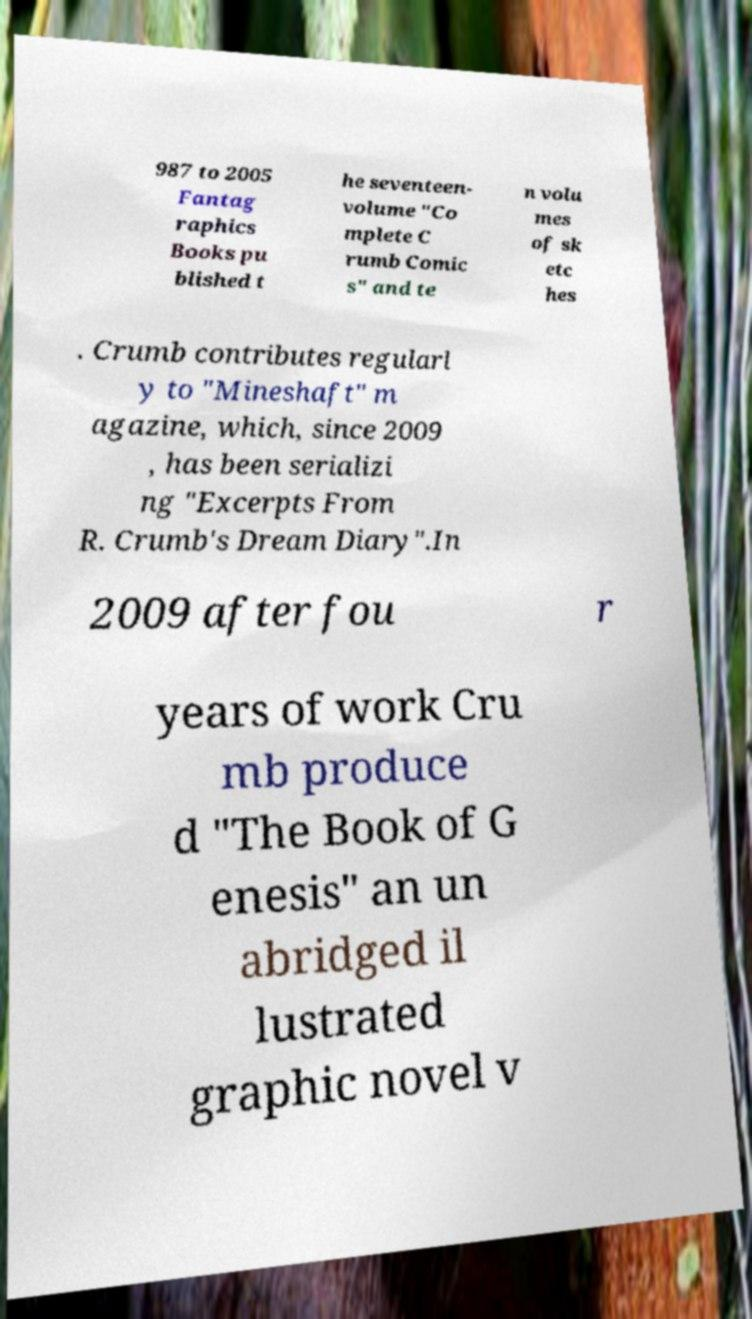For documentation purposes, I need the text within this image transcribed. Could you provide that? 987 to 2005 Fantag raphics Books pu blished t he seventeen- volume "Co mplete C rumb Comic s" and te n volu mes of sk etc hes . Crumb contributes regularl y to "Mineshaft" m agazine, which, since 2009 , has been serializi ng "Excerpts From R. Crumb's Dream Diary".In 2009 after fou r years of work Cru mb produce d "The Book of G enesis" an un abridged il lustrated graphic novel v 